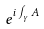Convert formula to latex. <formula><loc_0><loc_0><loc_500><loc_500>e ^ { i \int _ { \gamma } A }</formula> 